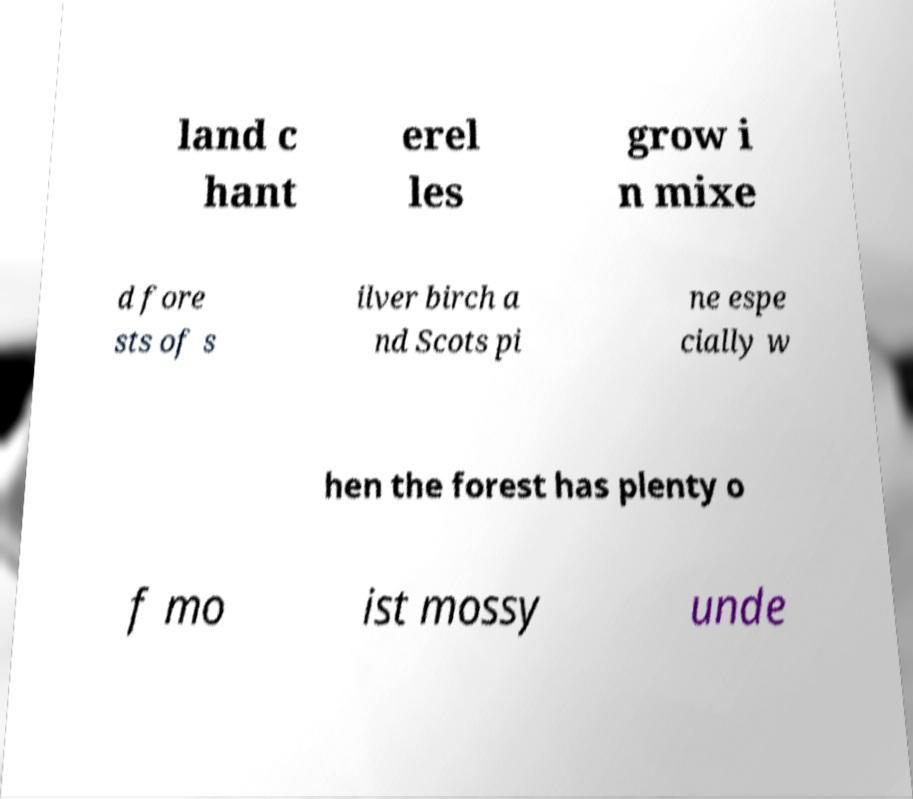What messages or text are displayed in this image? I need them in a readable, typed format. land c hant erel les grow i n mixe d fore sts of s ilver birch a nd Scots pi ne espe cially w hen the forest has plenty o f mo ist mossy unde 